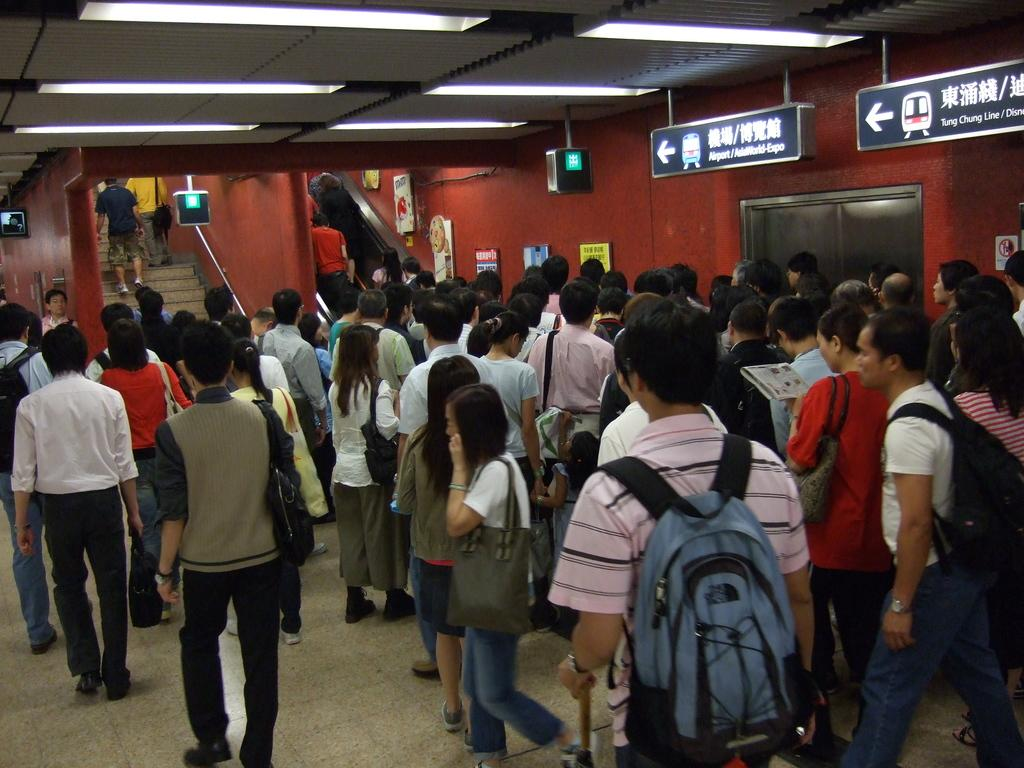How many people are present in the image? There are multiple people in the image. What are some of the people in the image doing? Some people are standing. What items are some people carrying in the image? Some people are carrying backpacks. What type of smoke can be seen coming from the backpacks in the image? There is no smoke present in the image, and backpacks are not producing any smoke. 